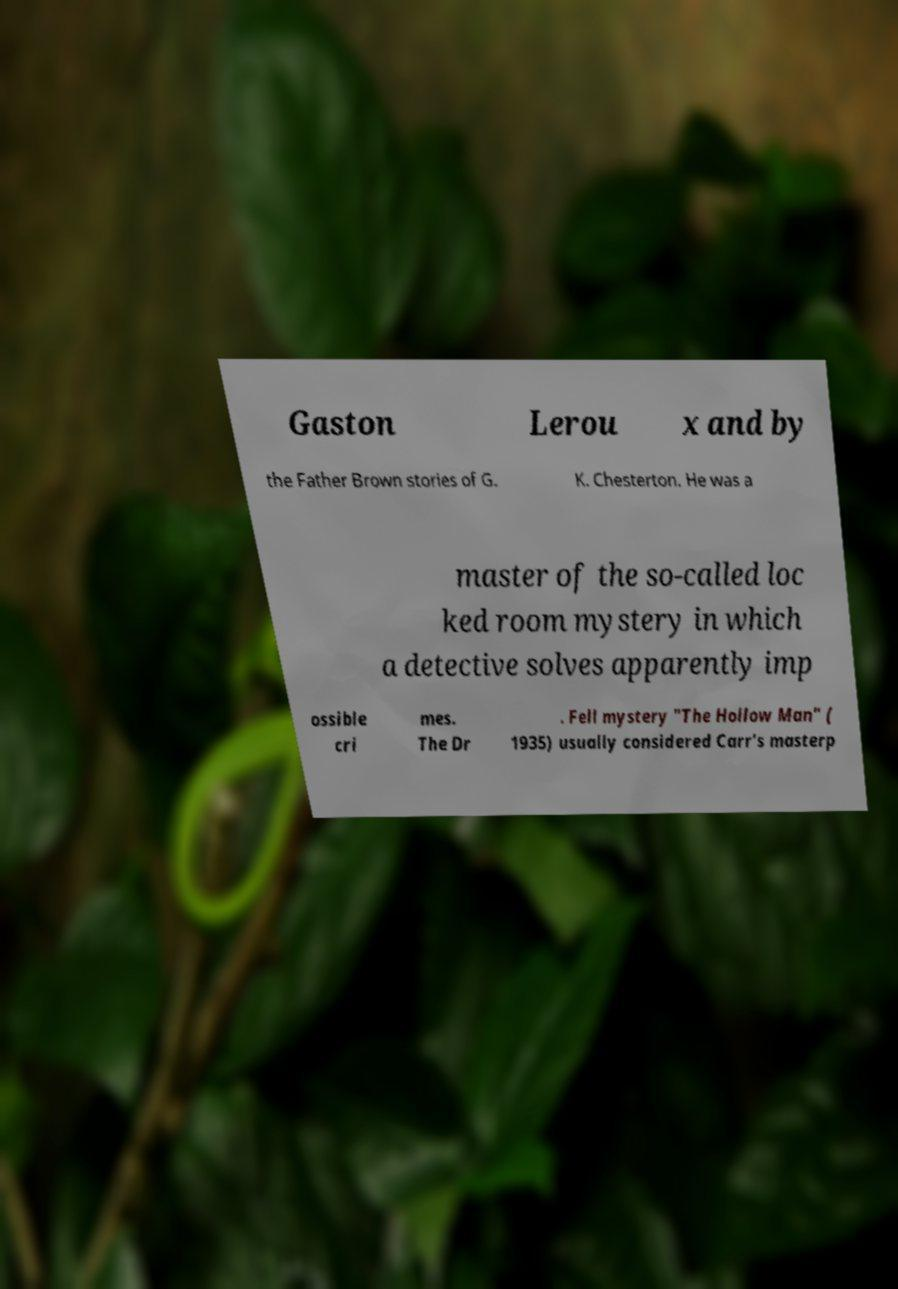Could you extract and type out the text from this image? Gaston Lerou x and by the Father Brown stories of G. K. Chesterton. He was a master of the so-called loc ked room mystery in which a detective solves apparently imp ossible cri mes. The Dr . Fell mystery "The Hollow Man" ( 1935) usually considered Carr's masterp 